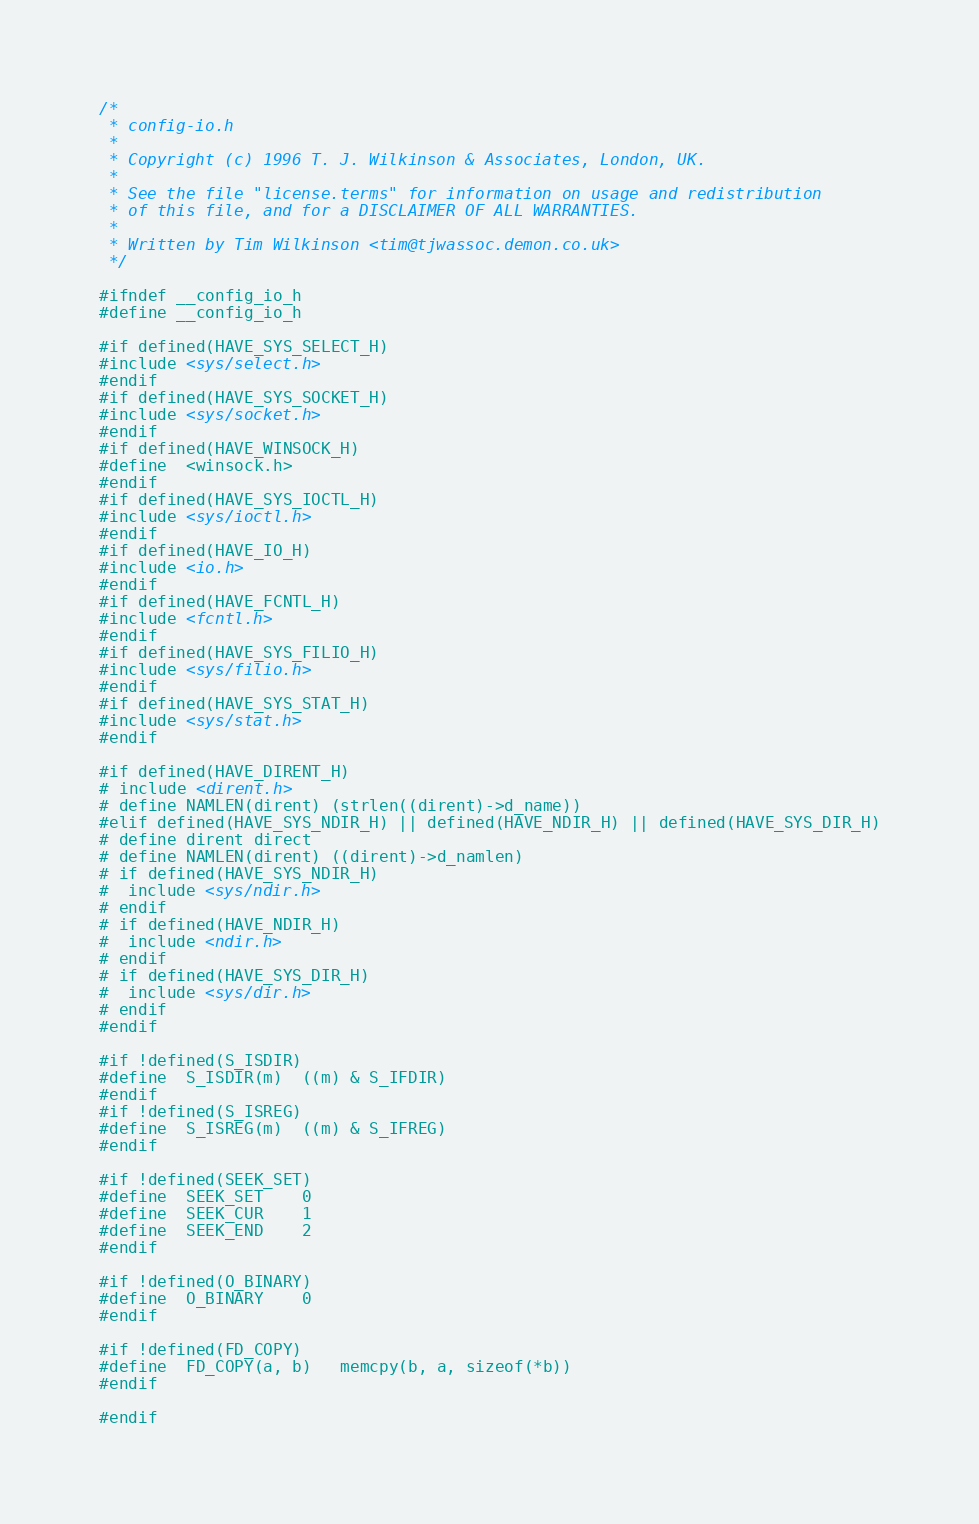Convert code to text. <code><loc_0><loc_0><loc_500><loc_500><_C_>/*
 * config-io.h
 *
 * Copyright (c) 1996 T. J. Wilkinson & Associates, London, UK.
 *
 * See the file "license.terms" for information on usage and redistribution
 * of this file, and for a DISCLAIMER OF ALL WARRANTIES.
 *
 * Written by Tim Wilkinson <tim@tjwassoc.demon.co.uk>
 */

#ifndef __config_io_h
#define __config_io_h

#if defined(HAVE_SYS_SELECT_H)
#include <sys/select.h>
#endif
#if defined(HAVE_SYS_SOCKET_H)
#include <sys/socket.h>
#endif
#if defined(HAVE_WINSOCK_H)
#define	<winsock.h>
#endif
#if defined(HAVE_SYS_IOCTL_H)
#include <sys/ioctl.h>
#endif
#if defined(HAVE_IO_H)
#include <io.h>
#endif
#if defined(HAVE_FCNTL_H)
#include <fcntl.h>
#endif
#if defined(HAVE_SYS_FILIO_H)
#include <sys/filio.h>
#endif
#if defined(HAVE_SYS_STAT_H)
#include <sys/stat.h>
#endif

#if defined(HAVE_DIRENT_H)
# include <dirent.h>
# define NAMLEN(dirent) (strlen((dirent)->d_name))
#elif defined(HAVE_SYS_NDIR_H) || defined(HAVE_NDIR_H) || defined(HAVE_SYS_DIR_H)
# define dirent direct
# define NAMLEN(dirent) ((dirent)->d_namlen)
# if defined(HAVE_SYS_NDIR_H)
#  include <sys/ndir.h>
# endif
# if defined(HAVE_NDIR_H)
#  include <ndir.h>
# endif
# if defined(HAVE_SYS_DIR_H)
#  include <sys/dir.h>
# endif
#endif

#if !defined(S_ISDIR)
#define	S_ISDIR(m)	((m) & S_IFDIR)
#endif
#if !defined(S_ISREG)
#define	S_ISREG(m)	((m) & S_IFREG)
#endif

#if !defined(SEEK_SET)
#define	SEEK_SET	0
#define	SEEK_CUR	1
#define	SEEK_END	2
#endif

#if !defined(O_BINARY)
#define	O_BINARY	0
#endif

#if !defined(FD_COPY)
#define	FD_COPY(a, b)	memcpy(b, a, sizeof(*b))
#endif

#endif
</code> 